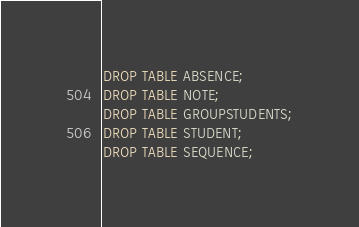Convert code to text. <code><loc_0><loc_0><loc_500><loc_500><_SQL_>DROP TABLE ABSENCE;
DROP TABLE NOTE;
DROP TABLE GROUPSTUDENTS;
DROP TABLE STUDENT;
DROP TABLE SEQUENCE;
</code> 